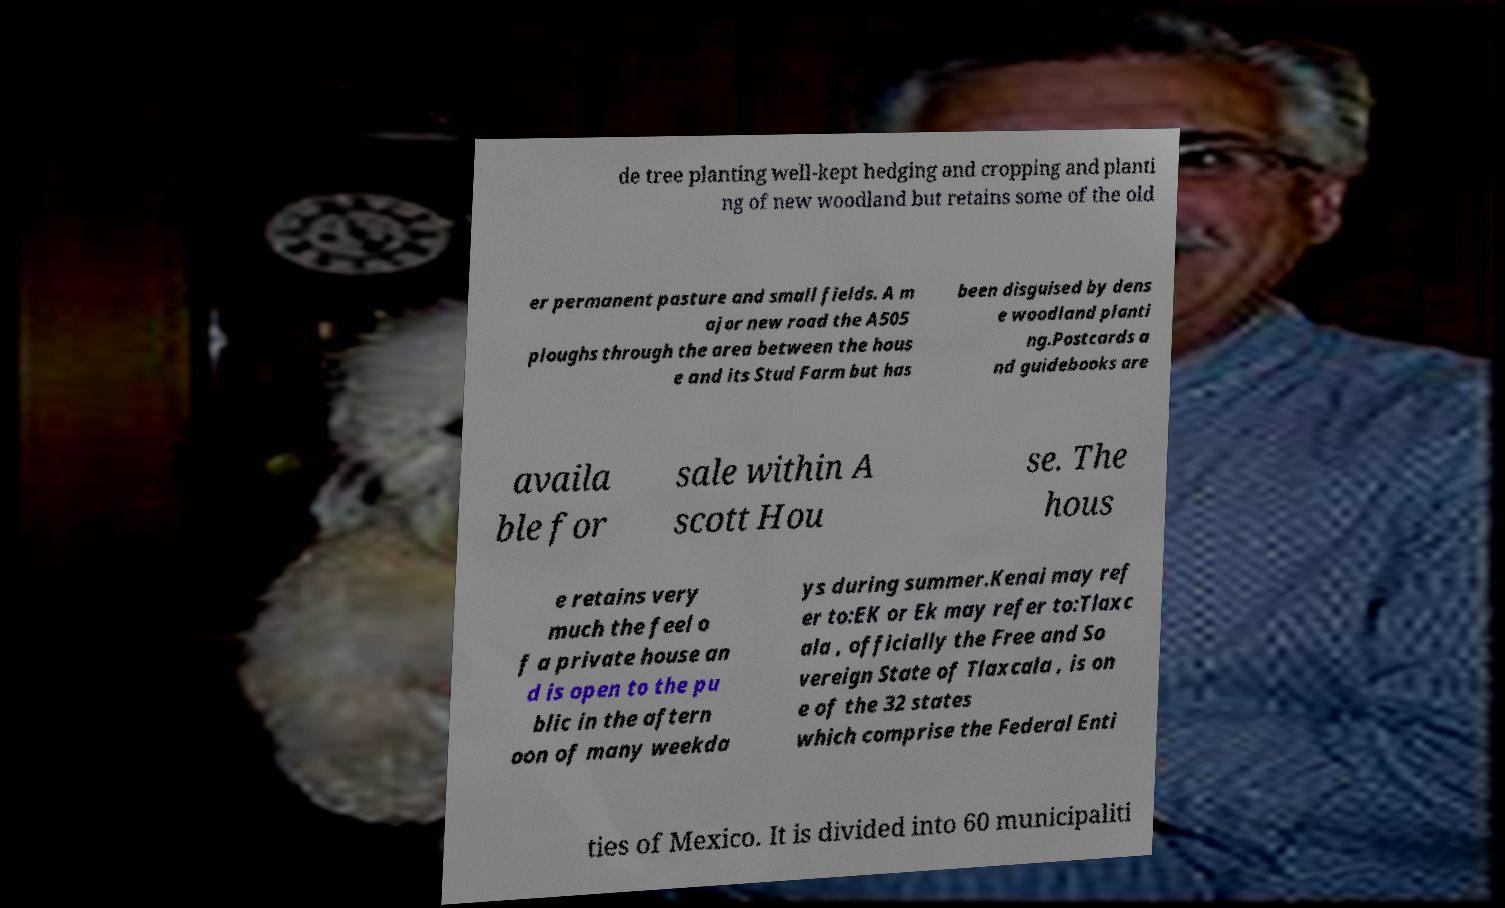Could you extract and type out the text from this image? de tree planting well-kept hedging and cropping and planti ng of new woodland but retains some of the old er permanent pasture and small fields. A m ajor new road the A505 ploughs through the area between the hous e and its Stud Farm but has been disguised by dens e woodland planti ng.Postcards a nd guidebooks are availa ble for sale within A scott Hou se. The hous e retains very much the feel o f a private house an d is open to the pu blic in the aftern oon of many weekda ys during summer.Kenai may ref er to:EK or Ek may refer to:Tlaxc ala , officially the Free and So vereign State of Tlaxcala , is on e of the 32 states which comprise the Federal Enti ties of Mexico. It is divided into 60 municipaliti 